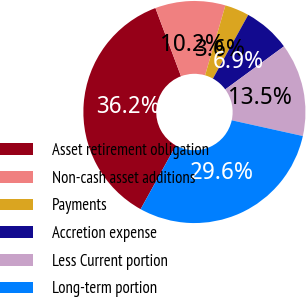Convert chart to OTSL. <chart><loc_0><loc_0><loc_500><loc_500><pie_chart><fcel>Asset retirement obligation<fcel>Non-cash asset additions<fcel>Payments<fcel>Accretion expense<fcel>Less Current portion<fcel>Long-term portion<nl><fcel>36.24%<fcel>10.21%<fcel>3.55%<fcel>6.88%<fcel>13.54%<fcel>29.58%<nl></chart> 